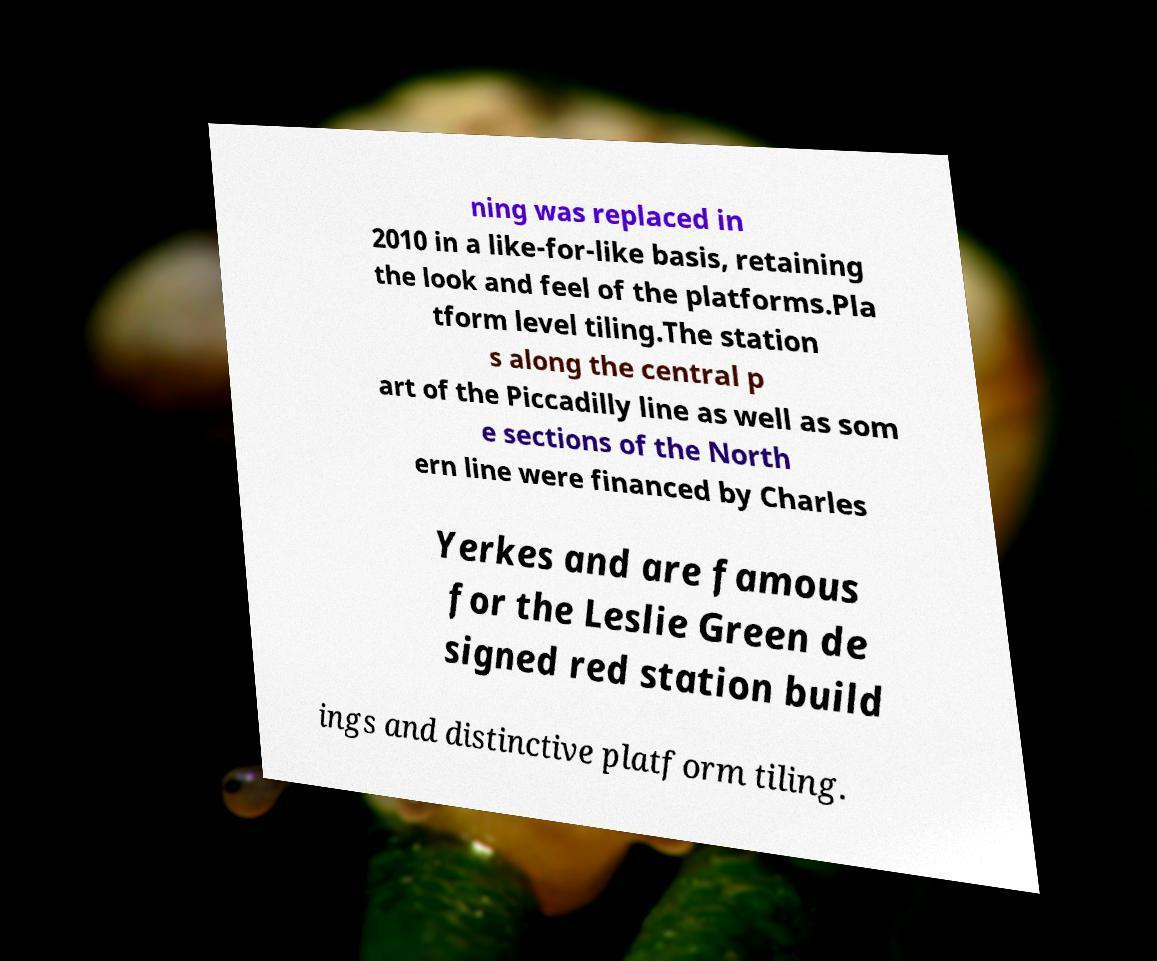I need the written content from this picture converted into text. Can you do that? ning was replaced in 2010 in a like-for-like basis, retaining the look and feel of the platforms.Pla tform level tiling.The station s along the central p art of the Piccadilly line as well as som e sections of the North ern line were financed by Charles Yerkes and are famous for the Leslie Green de signed red station build ings and distinctive platform tiling. 